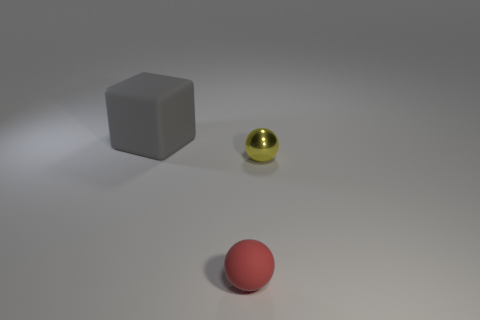What could be the possible uses of these items if they were real physical objects? If these items were tangible objects in the real world, the red sphere could be a rubber ball, commonly used for various games and exercises. The grey cube could represent a die, which is often used in board games, or it could be a paperweight if it's heavier. The small yellow sphere could be a marble, used for playing games or as a decorative element. 